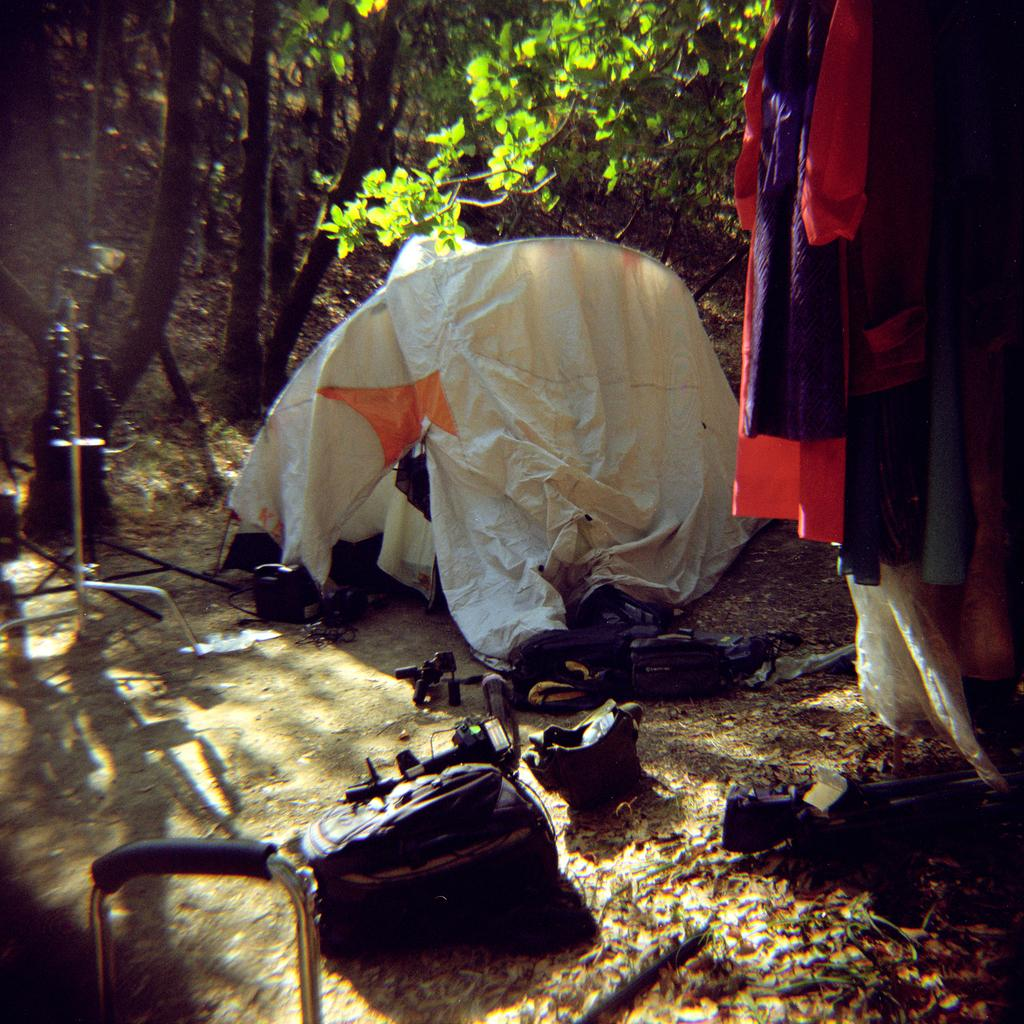What is the color of the tent in the image? The tent in the image is white. What can be seen behind the tent? Trees are visible behind the tent. What is located in front of the tent? Bags, a camera, a stand, and some clothes are visible in front of the tent. How does the tent sort the screws in the image? The tent does not sort screws in the image; it is a tent and not an object designed for sorting. 